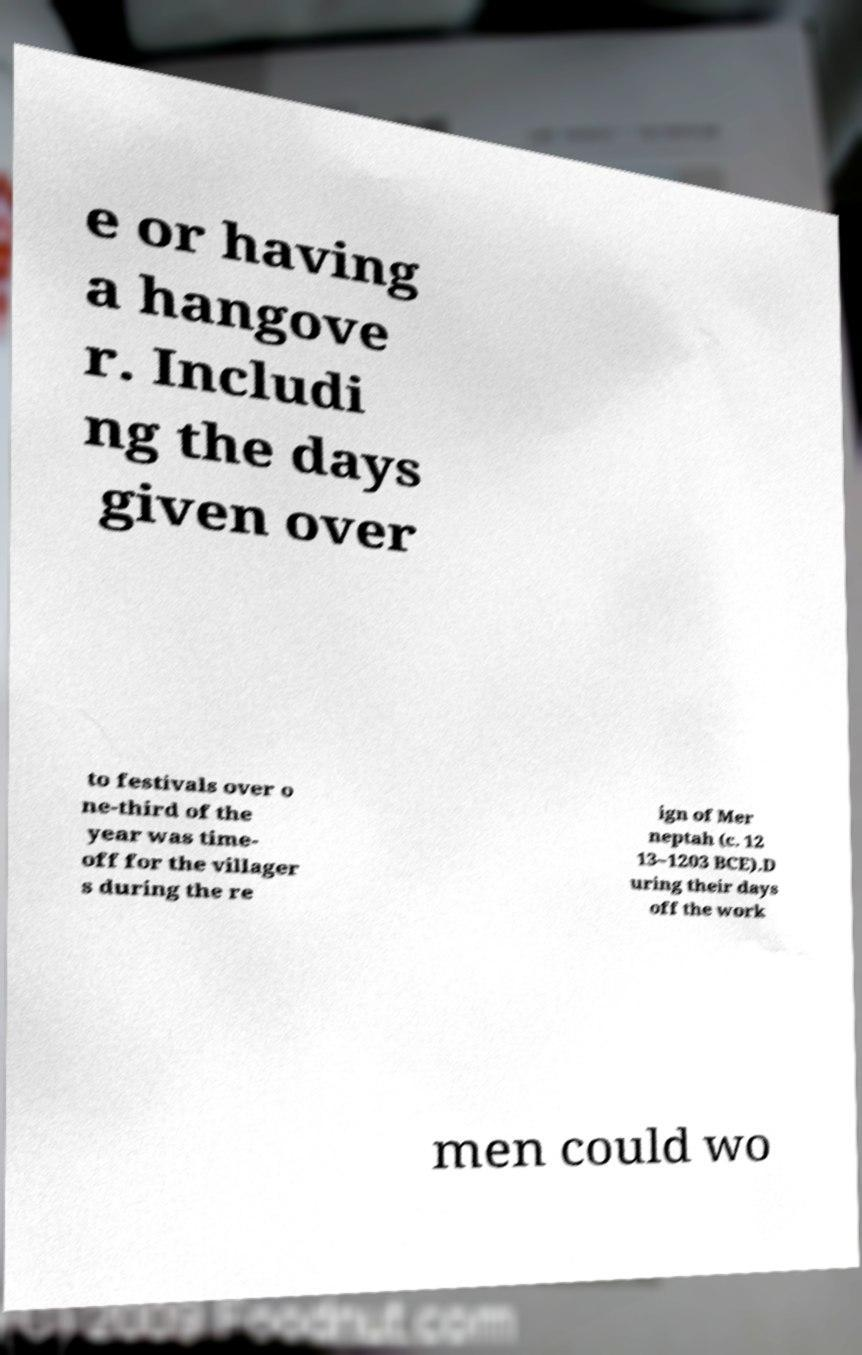There's text embedded in this image that I need extracted. Can you transcribe it verbatim? e or having a hangove r. Includi ng the days given over to festivals over o ne-third of the year was time- off for the villager s during the re ign of Mer neptah (c. 12 13–1203 BCE).D uring their days off the work men could wo 